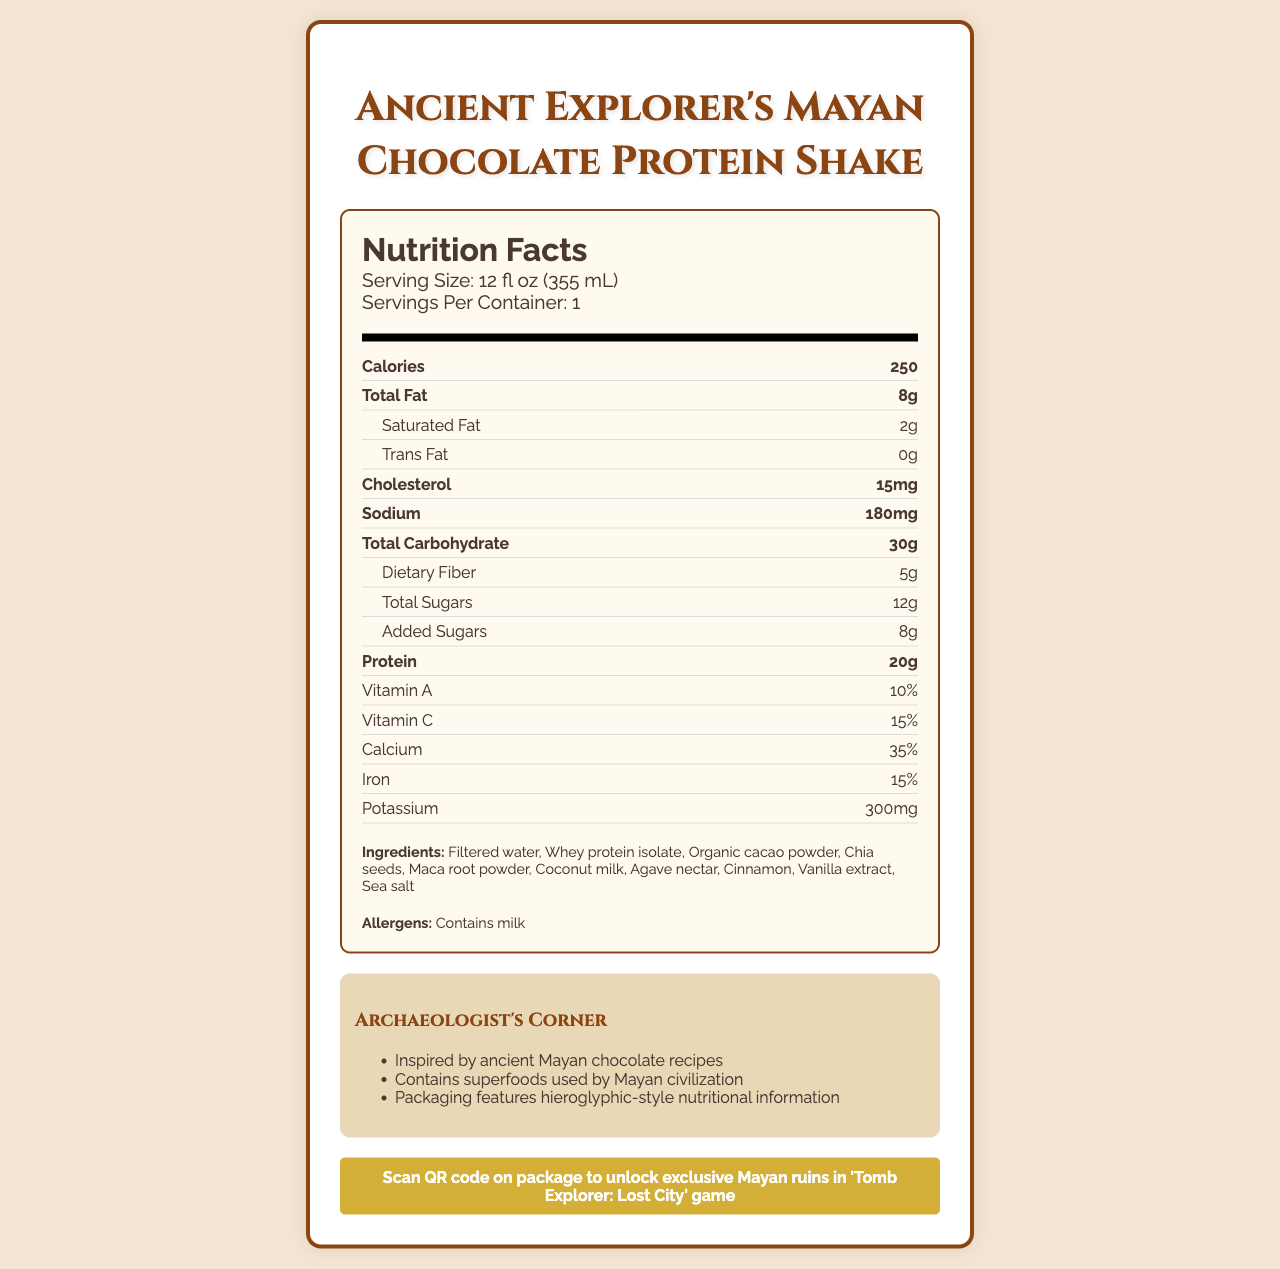What is the serving size of the Ancient Explorer's Mayan Chocolate Protein Shake? The serving size is explicitly listed under the nutrition information header as "Serving Size: 12 fl oz (355 mL)".
Answer: 12 fl oz (355 mL) How many calories are in one serving of the protein shake? The document shows "Calories: 250" under the nutrition facts section.
Answer: 250 How much protein does the shake contain? The protein content is listed under the nutrient row for protein, showing "Protein: 20g".
Answer: 20g What are the main allergens in this product? The allergens section of the document mentions "Contains milk".
Answer: Contains milk What are the special features of the Ancient Explorer's Mayan Chocolate Protein Shake? These features are listed under the "special features" section.
Answer: Gluten-free, Non-GMO, No artificial flavors or preservatives What percentage of daily Vitamin C intake does the shake provide? The document lists "Vitamin C: 15%" under the nutrient section.
Answer: 15% What is the sodium content in the shake in milligrams? The sodium content is listed as "Sodium: 180mg" in the nutrient facts.
Answer: 180mg What inspired the packaging design of this product? A. Greek architecture B. Egyptian pyramids C. Mayan pyramids D. Roman coliseums The package material and details section mentions that the packaging is "Inspired by the Mayan pyramids of Chichen Itza."
Answer: C What is used as a sweetener in the shake? A. Cane sugar B. Honey C. Stevia D. Agave nectar The ingredients list includes "Agave nectar" as one of the components.
Answer: D Is the container for the shake recyclable? The package material section states that the container is "100% recyclable BPA-free plastic".
Answer: Yes Summarize the main idea of this document. The document provides comprehensive nutrition facts and ingredients for the protein shake, its packaging features which are inspired by Mayan pyramids, and additional bonuses such as the gamer bonus.
Answer: The document details the nutrition facts, ingredients, allergens, packaging details, and special features of the Ancient Explorer's Mayan Chocolate Protein Shake, highlighting its unique qualities and historical inspiration. What is the total number of sugars present in the shake? The total sugars are listed under the nutrient row with "Total Sugars: 12g".
Answer: 12g What unique bonus is provided to gamers who purchase this shake? The document contains a section for the gamer bonus mentioning that scanning the QR code will unlock exclusive content in a game.
Answer: Scan QR code on package to unlock exclusive Mayan ruins in 'Tomb Explorer: Lost City' game What percentage of calcium does the protein shake contain? The nutrient facts list "Calcium: 35%" in the relevant row.
Answer: 35% How does the document present the nutritional information to align with its archaeological theme? The archaeologist facts section mentions, "Packaging features hieroglyphic-style nutritional information."
Answer: Packaging features hieroglyphic-style nutritional information. What is the maximum capacity of the pyramid-shaped container in milliliters? The document does not provide details about the maximum capacity of the container in milliliters beyond the serving size of 355 mL.
Answer: Not enough information 